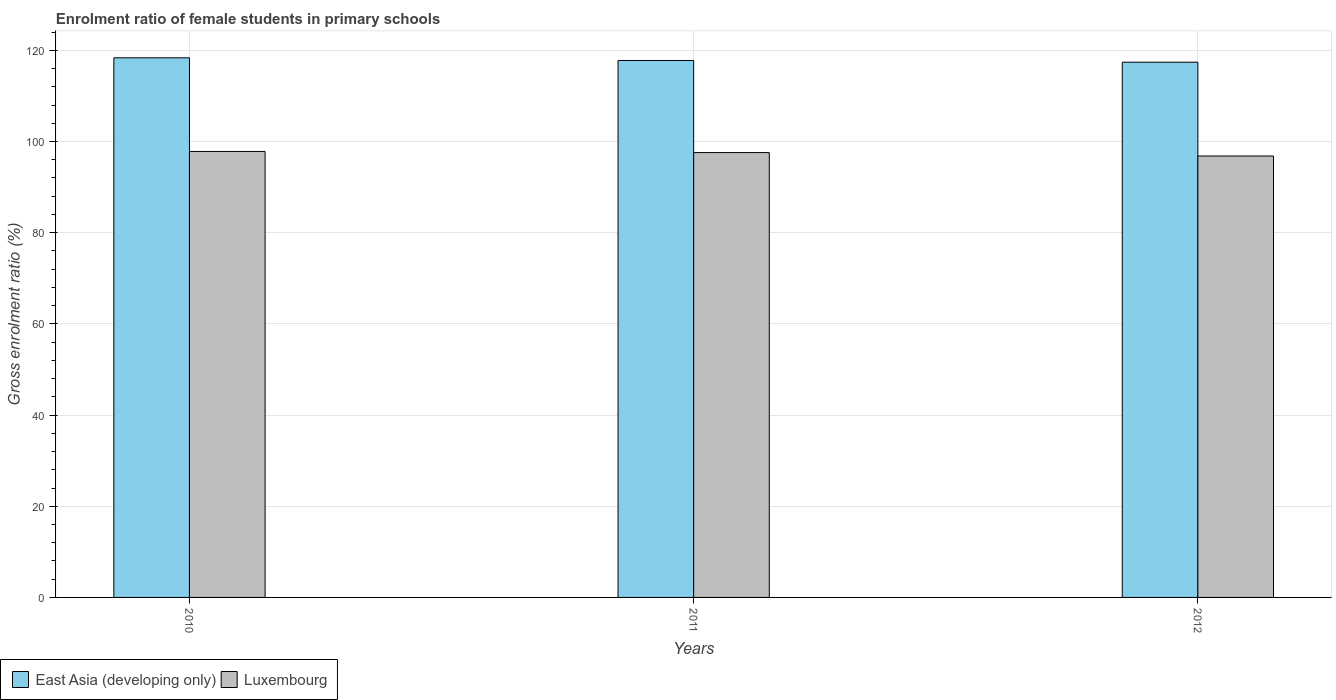Are the number of bars per tick equal to the number of legend labels?
Ensure brevity in your answer.  Yes. How many bars are there on the 2nd tick from the left?
Your answer should be very brief. 2. How many bars are there on the 1st tick from the right?
Your response must be concise. 2. What is the label of the 3rd group of bars from the left?
Ensure brevity in your answer.  2012. In how many cases, is the number of bars for a given year not equal to the number of legend labels?
Give a very brief answer. 0. What is the enrolment ratio of female students in primary schools in Luxembourg in 2012?
Your answer should be compact. 96.82. Across all years, what is the maximum enrolment ratio of female students in primary schools in East Asia (developing only)?
Provide a succinct answer. 118.35. Across all years, what is the minimum enrolment ratio of female students in primary schools in East Asia (developing only)?
Give a very brief answer. 117.39. In which year was the enrolment ratio of female students in primary schools in Luxembourg maximum?
Your answer should be compact. 2010. What is the total enrolment ratio of female students in primary schools in Luxembourg in the graph?
Your response must be concise. 292.2. What is the difference between the enrolment ratio of female students in primary schools in East Asia (developing only) in 2011 and that in 2012?
Keep it short and to the point. 0.38. What is the difference between the enrolment ratio of female students in primary schools in Luxembourg in 2011 and the enrolment ratio of female students in primary schools in East Asia (developing only) in 2010?
Provide a succinct answer. -20.79. What is the average enrolment ratio of female students in primary schools in East Asia (developing only) per year?
Your answer should be compact. 117.84. In the year 2010, what is the difference between the enrolment ratio of female students in primary schools in East Asia (developing only) and enrolment ratio of female students in primary schools in Luxembourg?
Make the answer very short. 20.54. In how many years, is the enrolment ratio of female students in primary schools in East Asia (developing only) greater than 56 %?
Ensure brevity in your answer.  3. What is the ratio of the enrolment ratio of female students in primary schools in East Asia (developing only) in 2010 to that in 2011?
Your answer should be very brief. 1. Is the difference between the enrolment ratio of female students in primary schools in East Asia (developing only) in 2010 and 2011 greater than the difference between the enrolment ratio of female students in primary schools in Luxembourg in 2010 and 2011?
Offer a terse response. Yes. What is the difference between the highest and the second highest enrolment ratio of female students in primary schools in Luxembourg?
Offer a very short reply. 0.25. What is the difference between the highest and the lowest enrolment ratio of female students in primary schools in East Asia (developing only)?
Your answer should be very brief. 0.96. In how many years, is the enrolment ratio of female students in primary schools in East Asia (developing only) greater than the average enrolment ratio of female students in primary schools in East Asia (developing only) taken over all years?
Offer a very short reply. 1. What does the 2nd bar from the left in 2011 represents?
Ensure brevity in your answer.  Luxembourg. What does the 1st bar from the right in 2011 represents?
Your answer should be compact. Luxembourg. Are all the bars in the graph horizontal?
Make the answer very short. No. Does the graph contain grids?
Your answer should be very brief. Yes. Where does the legend appear in the graph?
Make the answer very short. Bottom left. How are the legend labels stacked?
Offer a terse response. Horizontal. What is the title of the graph?
Ensure brevity in your answer.  Enrolment ratio of female students in primary schools. What is the Gross enrolment ratio (%) in East Asia (developing only) in 2010?
Ensure brevity in your answer.  118.35. What is the Gross enrolment ratio (%) of Luxembourg in 2010?
Ensure brevity in your answer.  97.82. What is the Gross enrolment ratio (%) of East Asia (developing only) in 2011?
Keep it short and to the point. 117.77. What is the Gross enrolment ratio (%) in Luxembourg in 2011?
Offer a very short reply. 97.57. What is the Gross enrolment ratio (%) of East Asia (developing only) in 2012?
Offer a very short reply. 117.39. What is the Gross enrolment ratio (%) of Luxembourg in 2012?
Offer a terse response. 96.82. Across all years, what is the maximum Gross enrolment ratio (%) of East Asia (developing only)?
Keep it short and to the point. 118.35. Across all years, what is the maximum Gross enrolment ratio (%) in Luxembourg?
Offer a terse response. 97.82. Across all years, what is the minimum Gross enrolment ratio (%) of East Asia (developing only)?
Offer a terse response. 117.39. Across all years, what is the minimum Gross enrolment ratio (%) of Luxembourg?
Provide a short and direct response. 96.82. What is the total Gross enrolment ratio (%) in East Asia (developing only) in the graph?
Your response must be concise. 353.51. What is the total Gross enrolment ratio (%) in Luxembourg in the graph?
Make the answer very short. 292.2. What is the difference between the Gross enrolment ratio (%) of East Asia (developing only) in 2010 and that in 2011?
Offer a terse response. 0.59. What is the difference between the Gross enrolment ratio (%) of Luxembourg in 2010 and that in 2011?
Provide a short and direct response. 0.25. What is the difference between the Gross enrolment ratio (%) in East Asia (developing only) in 2010 and that in 2012?
Offer a terse response. 0.96. What is the difference between the Gross enrolment ratio (%) in East Asia (developing only) in 2011 and that in 2012?
Offer a very short reply. 0.38. What is the difference between the Gross enrolment ratio (%) in Luxembourg in 2011 and that in 2012?
Provide a short and direct response. 0.75. What is the difference between the Gross enrolment ratio (%) in East Asia (developing only) in 2010 and the Gross enrolment ratio (%) in Luxembourg in 2011?
Provide a succinct answer. 20.79. What is the difference between the Gross enrolment ratio (%) of East Asia (developing only) in 2010 and the Gross enrolment ratio (%) of Luxembourg in 2012?
Ensure brevity in your answer.  21.54. What is the difference between the Gross enrolment ratio (%) of East Asia (developing only) in 2011 and the Gross enrolment ratio (%) of Luxembourg in 2012?
Give a very brief answer. 20.95. What is the average Gross enrolment ratio (%) of East Asia (developing only) per year?
Your response must be concise. 117.84. What is the average Gross enrolment ratio (%) of Luxembourg per year?
Your response must be concise. 97.4. In the year 2010, what is the difference between the Gross enrolment ratio (%) in East Asia (developing only) and Gross enrolment ratio (%) in Luxembourg?
Provide a succinct answer. 20.54. In the year 2011, what is the difference between the Gross enrolment ratio (%) in East Asia (developing only) and Gross enrolment ratio (%) in Luxembourg?
Your answer should be very brief. 20.2. In the year 2012, what is the difference between the Gross enrolment ratio (%) of East Asia (developing only) and Gross enrolment ratio (%) of Luxembourg?
Give a very brief answer. 20.58. What is the ratio of the Gross enrolment ratio (%) in Luxembourg in 2010 to that in 2011?
Offer a terse response. 1. What is the ratio of the Gross enrolment ratio (%) in East Asia (developing only) in 2010 to that in 2012?
Your answer should be very brief. 1.01. What is the ratio of the Gross enrolment ratio (%) of Luxembourg in 2010 to that in 2012?
Give a very brief answer. 1.01. What is the ratio of the Gross enrolment ratio (%) in Luxembourg in 2011 to that in 2012?
Offer a terse response. 1.01. What is the difference between the highest and the second highest Gross enrolment ratio (%) in East Asia (developing only)?
Offer a very short reply. 0.59. What is the difference between the highest and the second highest Gross enrolment ratio (%) of Luxembourg?
Offer a very short reply. 0.25. What is the difference between the highest and the lowest Gross enrolment ratio (%) in East Asia (developing only)?
Give a very brief answer. 0.96. 